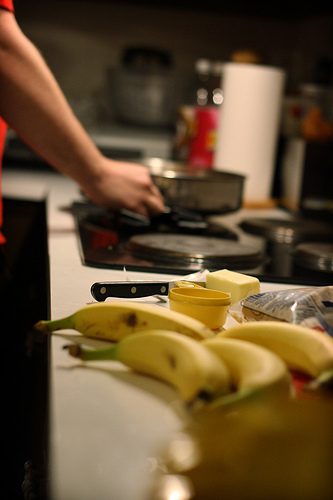What kind of fruit is to the left of the bag? To the left of the bag, there's a banana prominently placed among other kitchen items. 